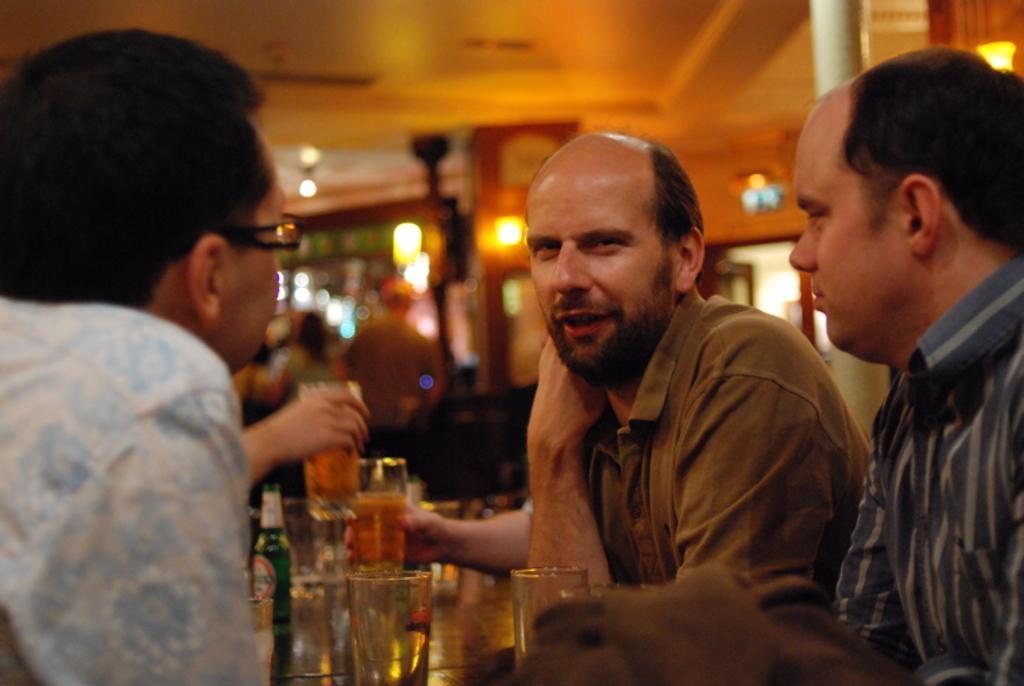In one or two sentences, can you explain what this image depicts? In this picture we can see three persons in the middle. These are the glasses and this is bottle. On the background we can see two persons standing on the floor and these are the lights. 